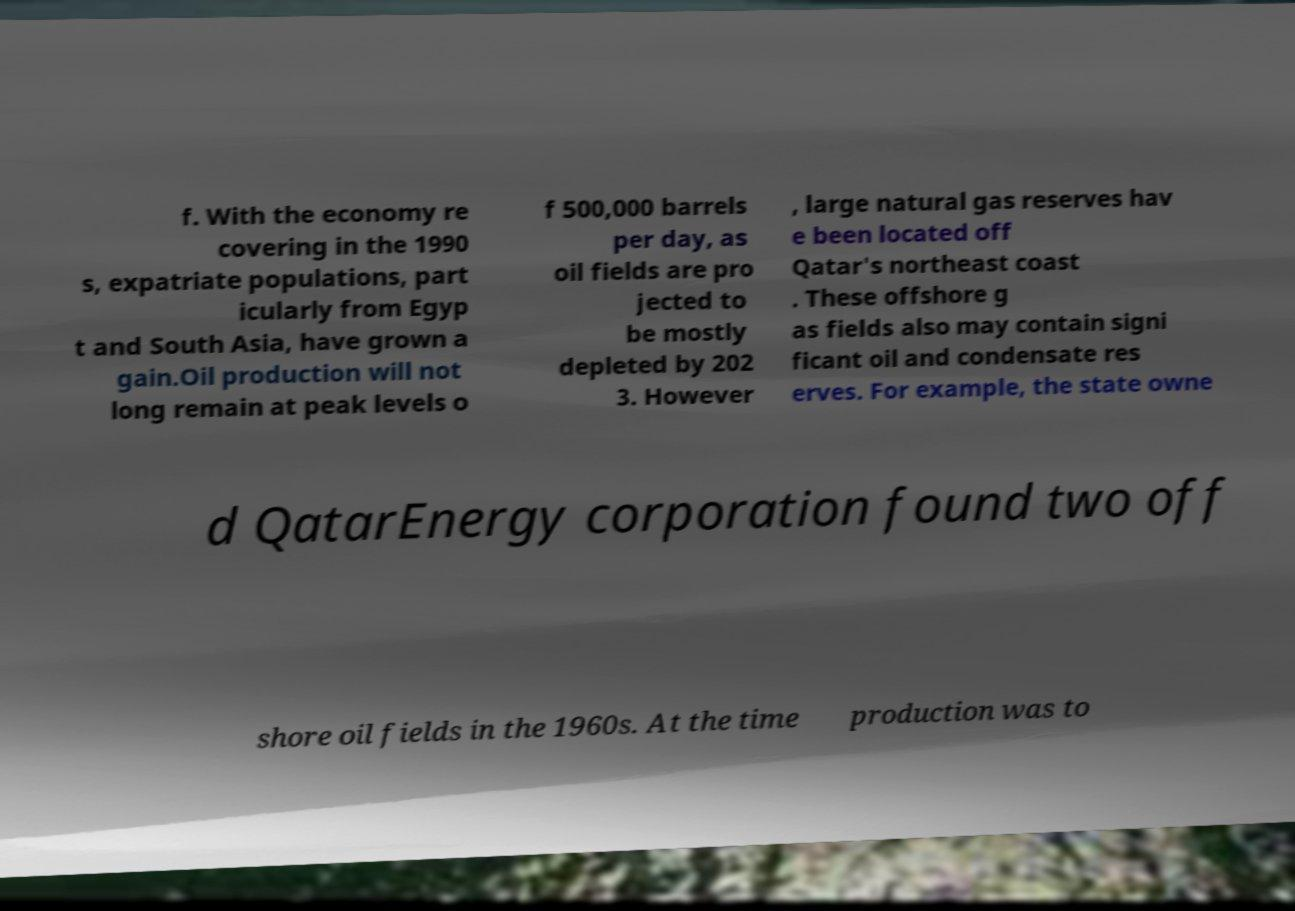Can you accurately transcribe the text from the provided image for me? f. With the economy re covering in the 1990 s, expatriate populations, part icularly from Egyp t and South Asia, have grown a gain.Oil production will not long remain at peak levels o f 500,000 barrels per day, as oil fields are pro jected to be mostly depleted by 202 3. However , large natural gas reserves hav e been located off Qatar's northeast coast . These offshore g as fields also may contain signi ficant oil and condensate res erves. For example, the state owne d QatarEnergy corporation found two off shore oil fields in the 1960s. At the time production was to 